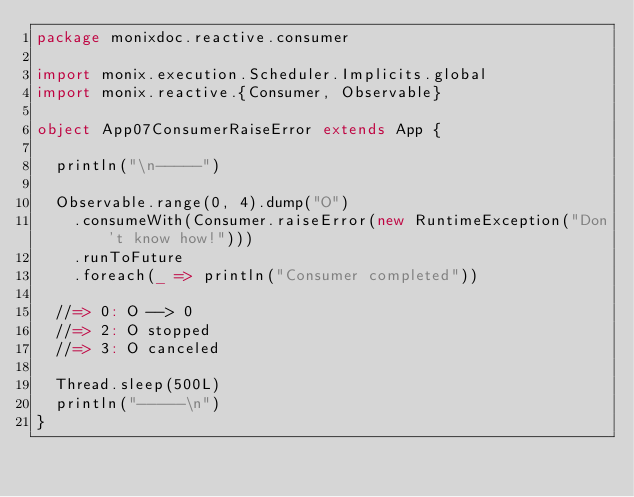Convert code to text. <code><loc_0><loc_0><loc_500><loc_500><_Scala_>package monixdoc.reactive.consumer

import monix.execution.Scheduler.Implicits.global
import monix.reactive.{Consumer, Observable}

object App07ConsumerRaiseError extends App {

  println("\n-----")

  Observable.range(0, 4).dump("O")
    .consumeWith(Consumer.raiseError(new RuntimeException("Don't know how!")))
    .runToFuture
    .foreach(_ => println("Consumer completed"))

  //=> 0: O --> 0
  //=> 2: O stopped
  //=> 3: O canceled

  Thread.sleep(500L)
  println("-----\n")
}
</code> 